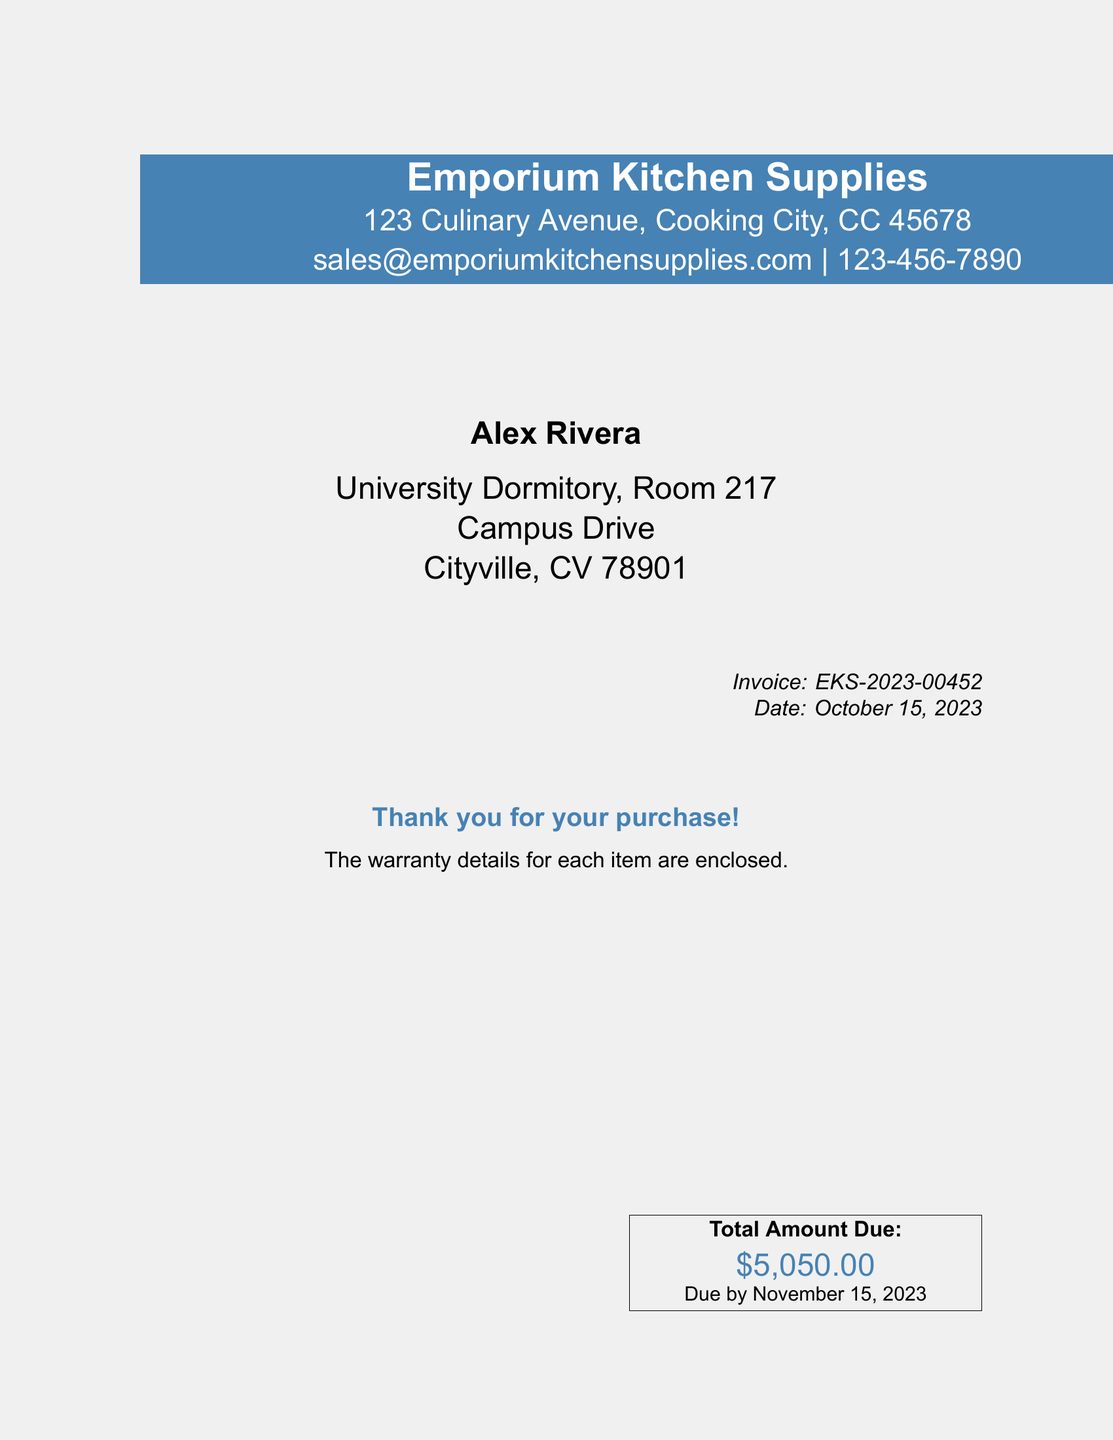What is the name of the supplier? The document lists the name of the supplier at the top, which is Emporium Kitchen Supplies.
Answer: Emporium Kitchen Supplies What is the total amount due? The total amount due is shown in a highlighted box at the bottom of the document.
Answer: $5,050.00 When is the payment due? The due date for payment is specified in the total amount due section of the invoice.
Answer: November 15, 2023 What is the invoice number? The invoice number is located in the upper right corner of the document.
Answer: EKS-2023-00452 What is the address of the supplier? The address of the supplier is provided under their name in the document.
Answer: 123 Culinary Avenue, Cooking City, CC 45678 What is the email address of the supplier? The document includes the email address of the supplier near the top.
Answer: sales@emporiumkitchensupplies.com Who is the invoice addressed to? The name of the individual to whom the invoice is addressed can be found in the center section of the document.
Answer: Alex Rivera What is the date of the invoice? The date of the invoice is mentioned in the top right corner of the document.
Answer: October 15, 2023 